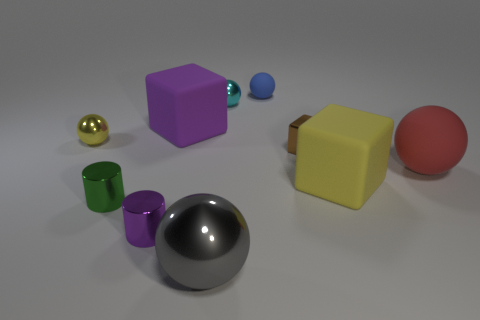Can you tell me the colors of the spherical objects in the image? Certainly! There are three spherical objects, each a different color. One is gold, another is red, and the third is blue. 